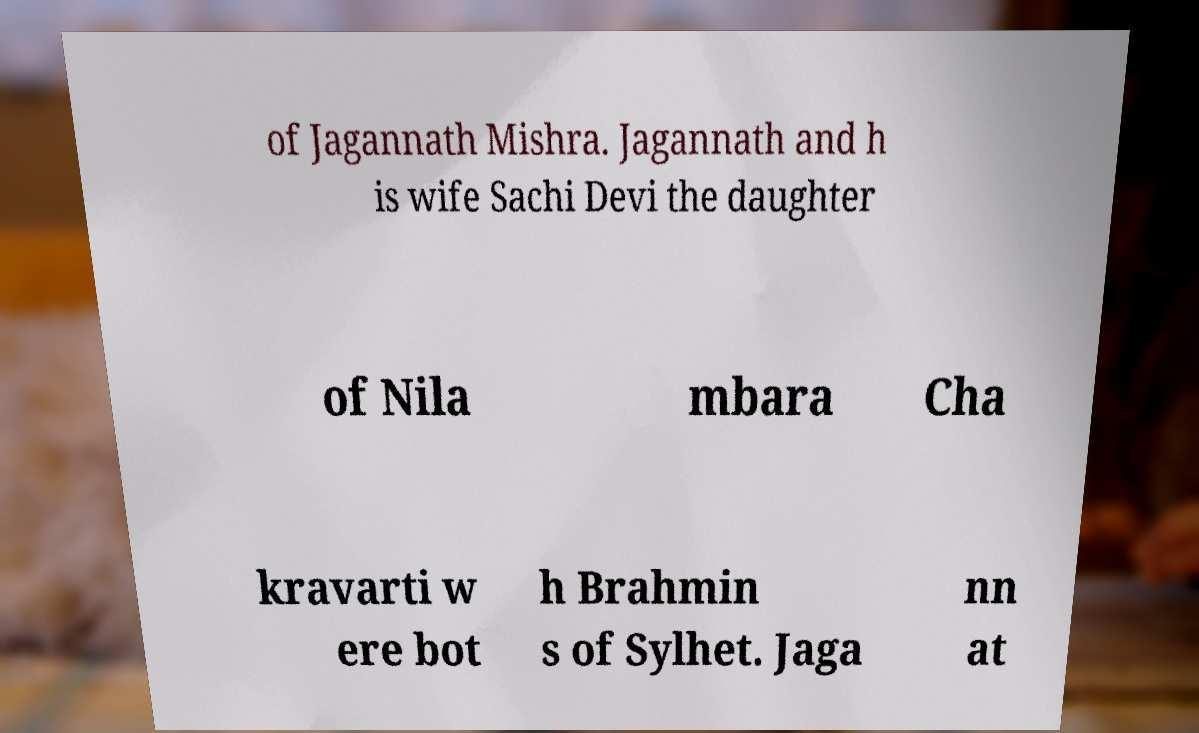Please read and relay the text visible in this image. What does it say? of Jagannath Mishra. Jagannath and h is wife Sachi Devi the daughter of Nila mbara Cha kravarti w ere bot h Brahmin s of Sylhet. Jaga nn at 